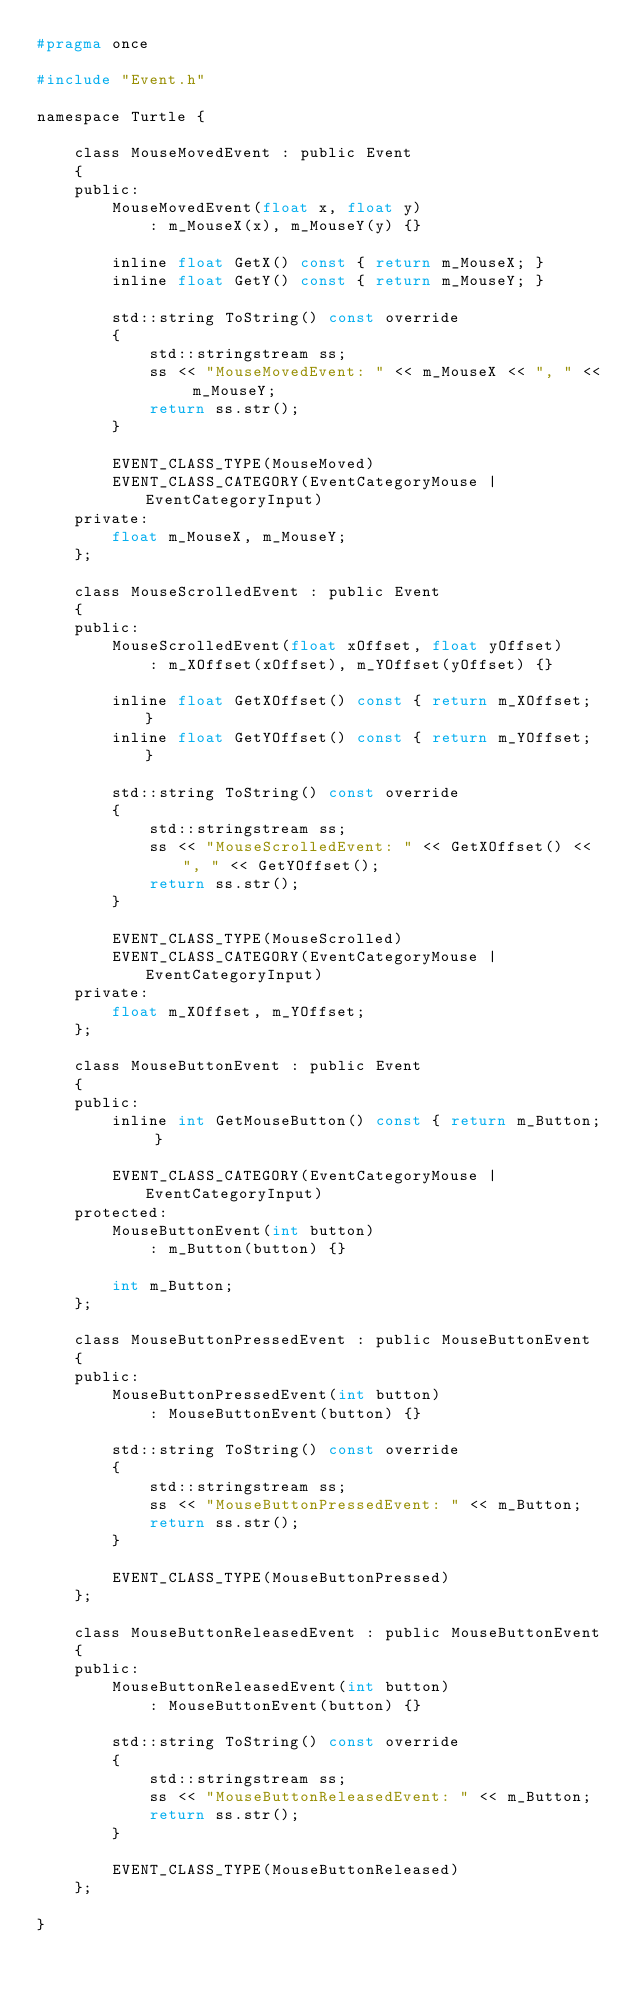<code> <loc_0><loc_0><loc_500><loc_500><_C_>#pragma once

#include "Event.h"

namespace Turtle {

	class MouseMovedEvent : public Event
	{
	public:
		MouseMovedEvent(float x, float y)
			: m_MouseX(x), m_MouseY(y) {}

		inline float GetX() const { return m_MouseX; }
		inline float GetY() const { return m_MouseY; }

		std::string ToString() const override
		{
			std::stringstream ss;
			ss << "MouseMovedEvent: " << m_MouseX << ", " << m_MouseY;
			return ss.str();
		}

		EVENT_CLASS_TYPE(MouseMoved)
		EVENT_CLASS_CATEGORY(EventCategoryMouse | EventCategoryInput)
	private:
		float m_MouseX, m_MouseY;
	};

	class MouseScrolledEvent : public Event
	{
	public:
		MouseScrolledEvent(float xOffset, float yOffset)
			: m_XOffset(xOffset), m_YOffset(yOffset) {}

		inline float GetXOffset() const { return m_XOffset; }
		inline float GetYOffset() const { return m_YOffset; }

		std::string ToString() const override
		{
			std::stringstream ss;
			ss << "MouseScrolledEvent: " << GetXOffset() << ", " << GetYOffset();
			return ss.str();
		}

		EVENT_CLASS_TYPE(MouseScrolled)
		EVENT_CLASS_CATEGORY(EventCategoryMouse | EventCategoryInput)
	private:
		float m_XOffset, m_YOffset;
	};

	class MouseButtonEvent : public Event
	{
	public:
		inline int GetMouseButton() const { return m_Button; }

		EVENT_CLASS_CATEGORY(EventCategoryMouse | EventCategoryInput)
	protected:
		MouseButtonEvent(int button)
			: m_Button(button) {}

		int m_Button;
	};

	class MouseButtonPressedEvent : public MouseButtonEvent
	{
	public:
		MouseButtonPressedEvent(int button)
			: MouseButtonEvent(button) {}

		std::string ToString() const override
		{
			std::stringstream ss;
			ss << "MouseButtonPressedEvent: " << m_Button;
			return ss.str();
		}

		EVENT_CLASS_TYPE(MouseButtonPressed)
	};

	class MouseButtonReleasedEvent : public MouseButtonEvent
	{
	public:
		MouseButtonReleasedEvent(int button)
			: MouseButtonEvent(button) {}

		std::string ToString() const override
		{
			std::stringstream ss;
			ss << "MouseButtonReleasedEvent: " << m_Button;
			return ss.str();
		}

		EVENT_CLASS_TYPE(MouseButtonReleased)
	};

}</code> 